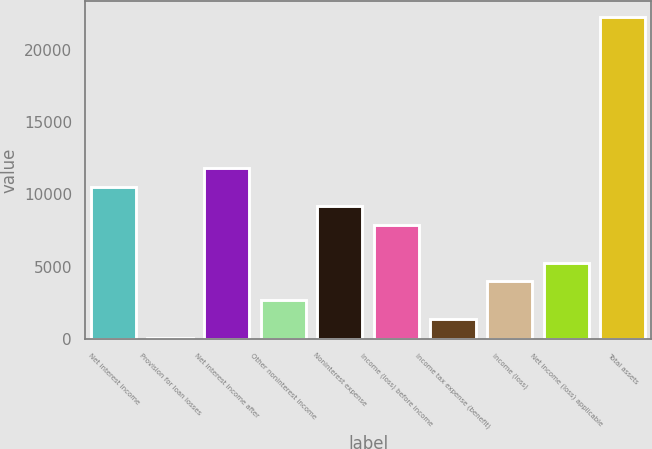Convert chart to OTSL. <chart><loc_0><loc_0><loc_500><loc_500><bar_chart><fcel>Net interest income<fcel>Provision for loan losses<fcel>Net interest income after<fcel>Other noninterest income<fcel>Noninterest expense<fcel>Income (loss) before income<fcel>Income tax expense (benefit)<fcel>Income (loss)<fcel>Net income (loss) applicable<fcel>Total assets<nl><fcel>10508<fcel>63.9<fcel>11813.5<fcel>2674.92<fcel>9202.47<fcel>7896.96<fcel>1369.41<fcel>3980.43<fcel>5285.94<fcel>22257.6<nl></chart> 